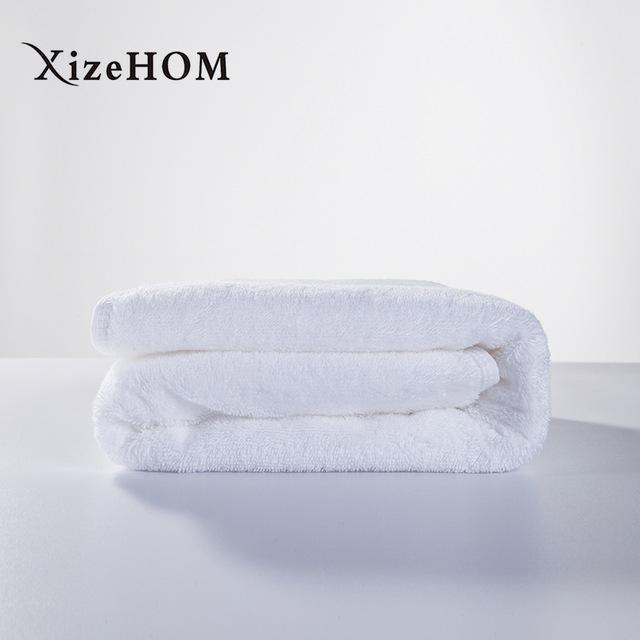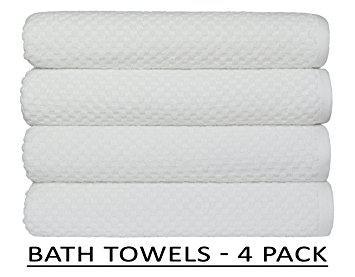The first image is the image on the left, the second image is the image on the right. Considering the images on both sides, is "the right image has 4 neatly folded and stacked bath towels" valid? Answer yes or no. Yes. The first image is the image on the left, the second image is the image on the right. Analyze the images presented: Is the assertion "In one of the images, there are towels that are not folded or rolled." valid? Answer yes or no. No. 